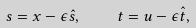<formula> <loc_0><loc_0><loc_500><loc_500>s = x - \epsilon \hat { s } , \quad t = u - \epsilon \hat { t } ,</formula> 